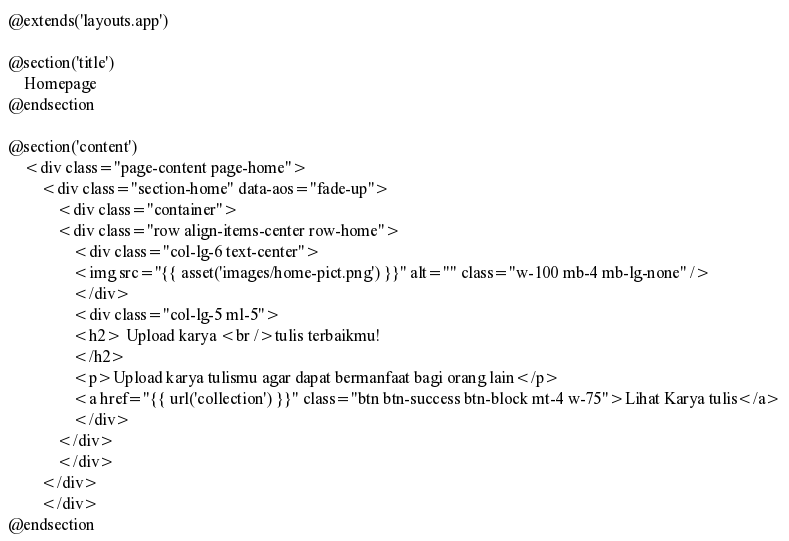Convert code to text. <code><loc_0><loc_0><loc_500><loc_500><_PHP_>@extends('layouts.app')

@section('title')
    Homepage
@endsection

@section('content')
    <div class="page-content page-home">
        <div class="section-home" data-aos="fade-up">
            <div class="container">
            <div class="row align-items-center row-home">
                <div class="col-lg-6 text-center">
                <img src="{{ asset('images/home-pict.png') }}" alt="" class="w-100 mb-4 mb-lg-none" />
                </div>
                <div class="col-lg-5 ml-5">
                <h2> Upload karya <br />tulis terbaikmu!
                </h2>
                <p>Upload karya tulismu agar dapat bermanfaat bagi orang lain</p>
                <a href="{{ url('collection') }}" class="btn btn-success btn-block mt-4 w-75">Lihat Karya tulis</a>
                </div>
            </div>
            </div>
        </div>
        </div>
@endsection
</code> 